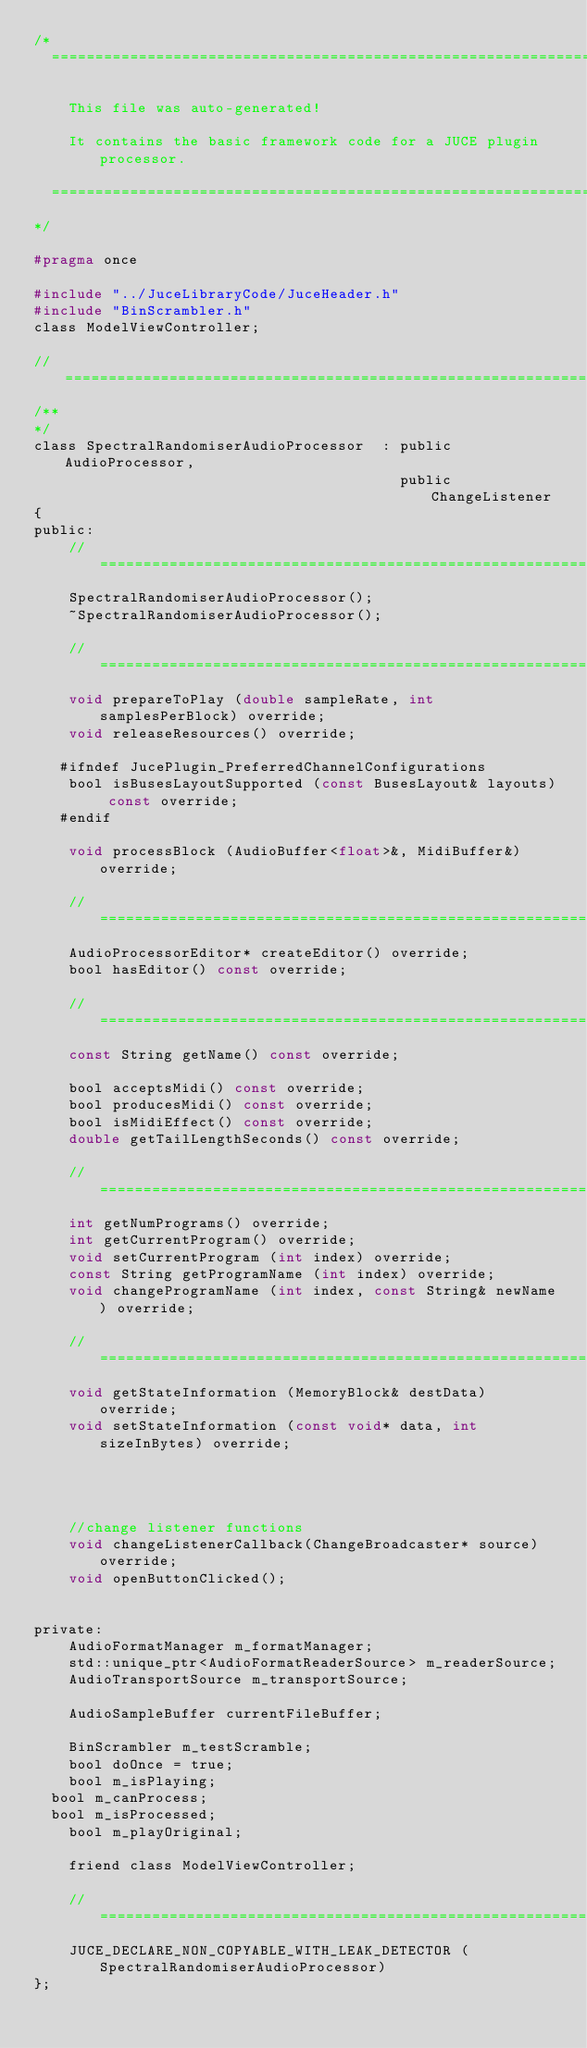Convert code to text. <code><loc_0><loc_0><loc_500><loc_500><_C_>/*
  ==============================================================================

    This file was auto-generated!

    It contains the basic framework code for a JUCE plugin processor.

  ==============================================================================
*/

#pragma once

#include "../JuceLibraryCode/JuceHeader.h"
#include "BinScrambler.h"
class ModelViewController;

//==============================================================================
/**
*/
class SpectralRandomiserAudioProcessor  : public AudioProcessor,
                                          public ChangeListener
{
public:
    //==============================================================================
    SpectralRandomiserAudioProcessor();
    ~SpectralRandomiserAudioProcessor();

    //==============================================================================
    void prepareToPlay (double sampleRate, int samplesPerBlock) override;
    void releaseResources() override;

   #ifndef JucePlugin_PreferredChannelConfigurations
    bool isBusesLayoutSupported (const BusesLayout& layouts) const override;
   #endif

    void processBlock (AudioBuffer<float>&, MidiBuffer&) override;

    //==============================================================================
    AudioProcessorEditor* createEditor() override;
    bool hasEditor() const override;

    //==============================================================================
    const String getName() const override;

    bool acceptsMidi() const override;
    bool producesMidi() const override;
    bool isMidiEffect() const override;
    double getTailLengthSeconds() const override;

    //==============================================================================
    int getNumPrograms() override;
    int getCurrentProgram() override;
    void setCurrentProgram (int index) override;
    const String getProgramName (int index) override;
    void changeProgramName (int index, const String& newName) override;

    //==============================================================================
    void getStateInformation (MemoryBlock& destData) override;
    void setStateInformation (const void* data, int sizeInBytes) override;



    
    //change listener functions
    void changeListenerCallback(ChangeBroadcaster* source) override;
    void openButtonClicked();
    

private:
    AudioFormatManager m_formatManager;
    std::unique_ptr<AudioFormatReaderSource> m_readerSource;
    AudioTransportSource m_transportSource;
    
    AudioSampleBuffer currentFileBuffer;
    
    BinScrambler m_testScramble;
    bool doOnce = true;
    bool m_isPlaying;
	bool m_canProcess;
	bool m_isProcessed;
    bool m_playOriginal;
    
    friend class ModelViewController;
    
    //==============================================================================
    JUCE_DECLARE_NON_COPYABLE_WITH_LEAK_DETECTOR (SpectralRandomiserAudioProcessor)
};
</code> 